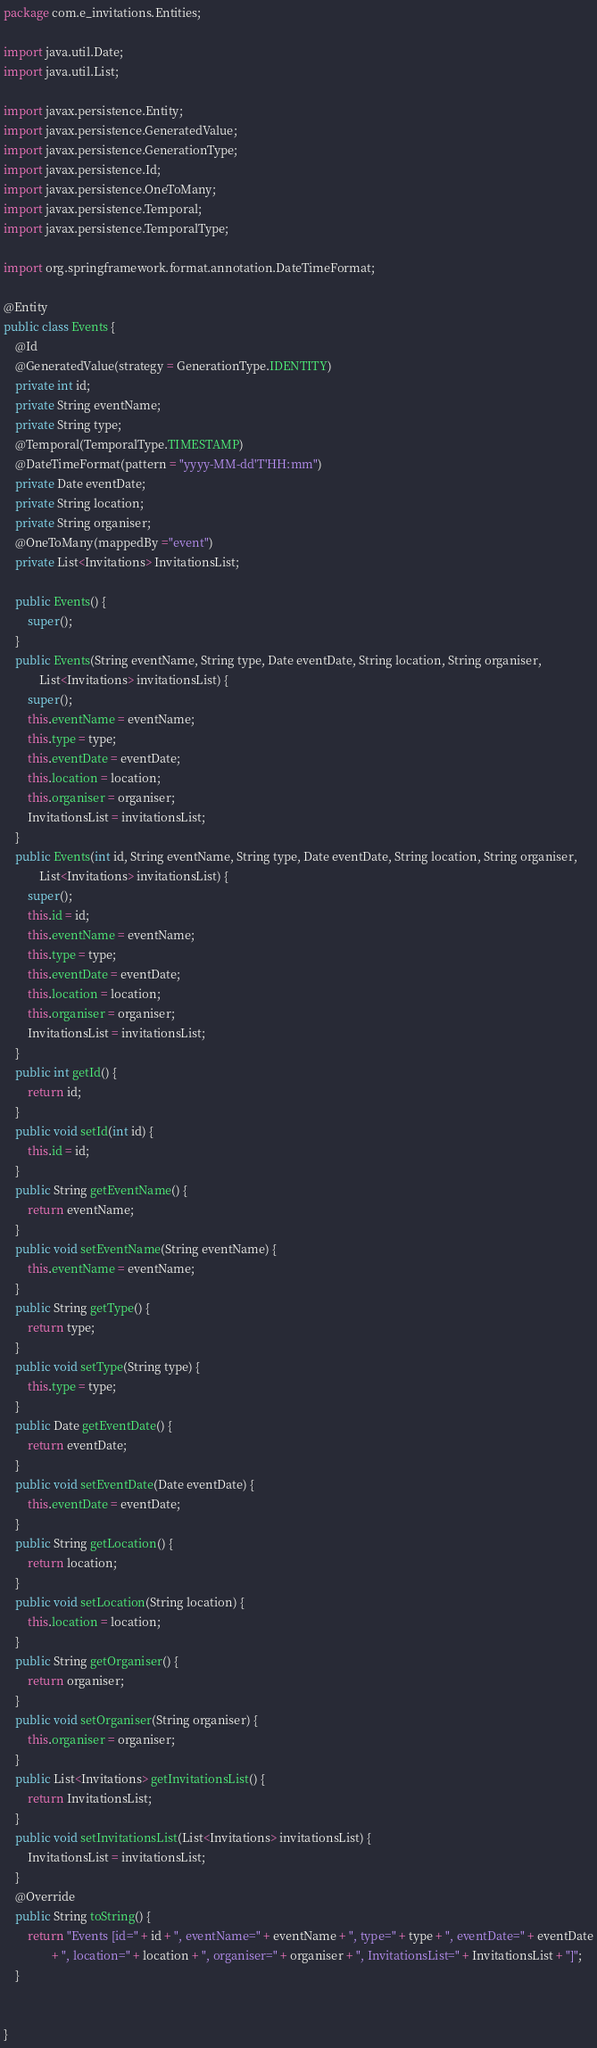<code> <loc_0><loc_0><loc_500><loc_500><_Java_>package com.e_invitations.Entities;

import java.util.Date;
import java.util.List;

import javax.persistence.Entity;
import javax.persistence.GeneratedValue;
import javax.persistence.GenerationType;
import javax.persistence.Id;
import javax.persistence.OneToMany;
import javax.persistence.Temporal;
import javax.persistence.TemporalType;

import org.springframework.format.annotation.DateTimeFormat;

@Entity
public class Events {
	@Id
	@GeneratedValue(strategy = GenerationType.IDENTITY)
	private int id;
	private String eventName;
	private String type;
	@Temporal(TemporalType.TIMESTAMP)
    @DateTimeFormat(pattern = "yyyy-MM-dd'T'HH:mm")
	private Date eventDate;
	private String location;
	private String organiser;
	@OneToMany(mappedBy ="event")
	private List<Invitations> InvitationsList;
	
	public Events() {
		super();
	}
	public Events(String eventName, String type, Date eventDate, String location, String organiser,
			List<Invitations> invitationsList) {
		super();
		this.eventName = eventName;
		this.type = type;
		this.eventDate = eventDate;
		this.location = location;
		this.organiser = organiser;
		InvitationsList = invitationsList;
	}
	public Events(int id, String eventName, String type, Date eventDate, String location, String organiser,
			List<Invitations> invitationsList) {
		super();
		this.id = id;
		this.eventName = eventName;
		this.type = type;
		this.eventDate = eventDate;
		this.location = location;
		this.organiser = organiser;
		InvitationsList = invitationsList;
	}
	public int getId() {
		return id;
	}
	public void setId(int id) {
		this.id = id;
	}
	public String getEventName() {
		return eventName;
	}
	public void setEventName(String eventName) {
		this.eventName = eventName;
	}
	public String getType() {
		return type;
	}
	public void setType(String type) {
		this.type = type;
	}
	public Date getEventDate() {
		return eventDate;
	}
	public void setEventDate(Date eventDate) {
		this.eventDate = eventDate;
	}
	public String getLocation() {
		return location;
	}
	public void setLocation(String location) {
		this.location = location;
	}
	public String getOrganiser() {
		return organiser;
	}
	public void setOrganiser(String organiser) {
		this.organiser = organiser;
	}
	public List<Invitations> getInvitationsList() {
		return InvitationsList;
	}
	public void setInvitationsList(List<Invitations> invitationsList) {
		InvitationsList = invitationsList;
	}
	@Override
	public String toString() {
		return "Events [id=" + id + ", eventName=" + eventName + ", type=" + type + ", eventDate=" + eventDate
				+ ", location=" + location + ", organiser=" + organiser + ", InvitationsList=" + InvitationsList + "]";
	}
	
	
}</code> 